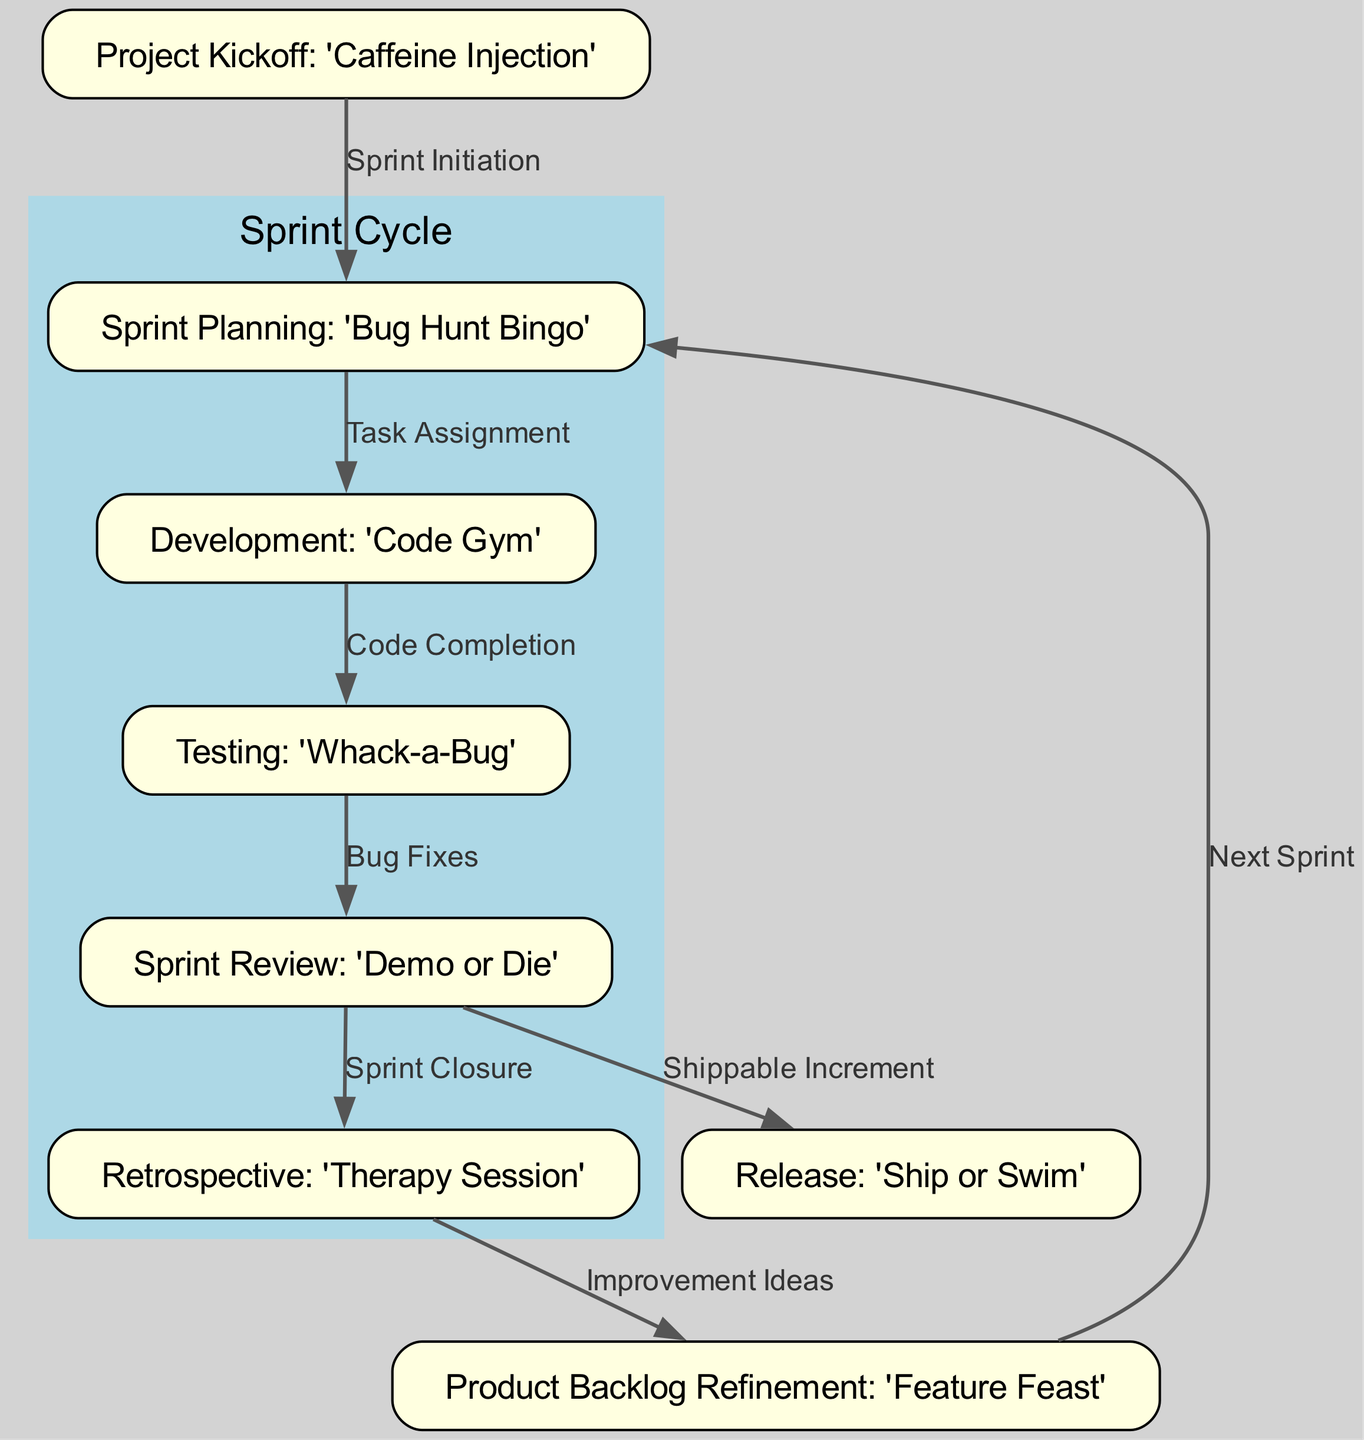What is the first milestone in the diagram? The first node is labeled "Project Kickoff: 'Caffeine Injection'", indicating it is the starting point of the project.
Answer: Project Kickoff: 'Caffeine Injection' How many nodes are there in the diagram? The diagram lists a total of eight nodes, each representing different stages or milestones in the software development lifecycle.
Answer: 8 What is the label connecting Development to Testing? The edge between the nodes "Development" and "Testing" is labeled "Code Completion", representing the transition from development to testing.
Answer: Code Completion Which milestone follows the Sprint Review? The diagram shows that after "Sprint Review: 'Demo or Die'", the next milestone is "Retrospective: 'Therapy Session'".
Answer: Retrospective: 'Therapy Session' What humorous name is given to the Testing stage? The node representing the Testing stage is called "Testing: 'Whack-a-Bug'", which reflects the playful approach taken in the agile process.
Answer: Testing: 'Whack-a-Bug' What is the overall theme of the milestone names in the diagram? The milestone names all incorporate humor, making light of the software development process while still reflecting the activities involved.
Answer: Humor Which phase directly leads to the Release phase? The direct connection to the "Release: 'Ship or Swim'" is from "Sprint Review: 'Demo or Die'", indicating this phase results in a shippable product.
Answer: Sprint Review: 'Demo or Die' What is the purpose of the edge labeled "Next Sprint"? The edge labeled "Next Sprint" indicates a transition from the "Product Backlog Refinement" to the "Sprint Planning" node, signifying the start of a new cycle after refining the backlog.
Answer: Next Sprint 